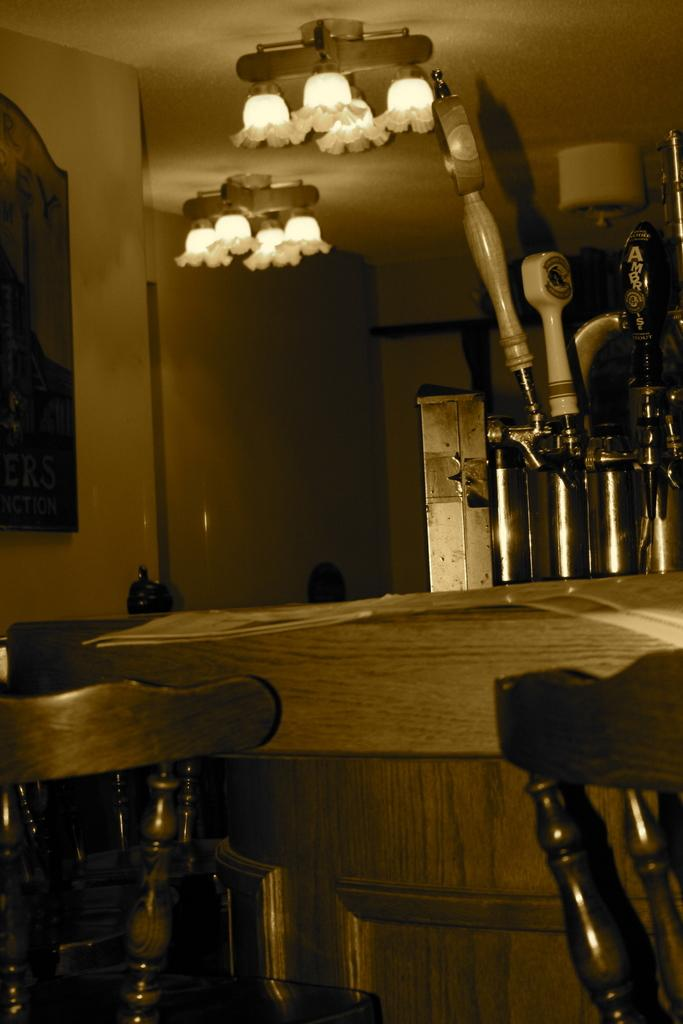What type of furniture is present in the image? There are chairs and a table in the image. What is the primary function of the table in the image? The table is likely used for placing objects or for eating. What can be seen in the background of the image? There are objects and lights in the background of the image. What is on the wall in the background of the image? There is a board on the wall in the background of the image. What type of fact can be seen in the jar on the table in the image? There is no jar present on the table in the image, and therefore no facts can be seen in a jar. 